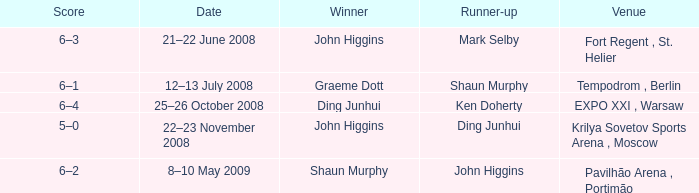When was the match that had Shaun Murphy as runner-up? 12–13 July 2008. 